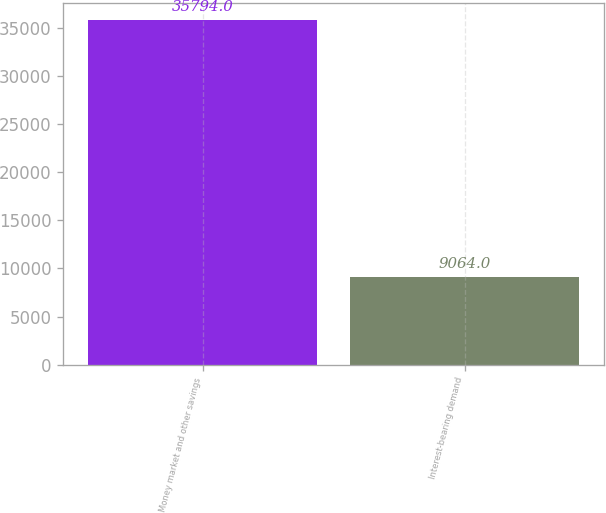Convert chart. <chart><loc_0><loc_0><loc_500><loc_500><bar_chart><fcel>Money market and other savings<fcel>Interest-bearing demand<nl><fcel>35794<fcel>9064<nl></chart> 